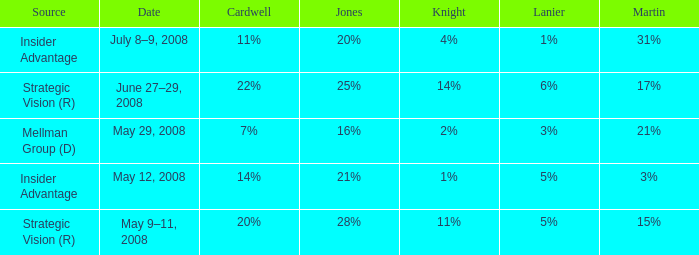Parse the table in full. {'header': ['Source', 'Date', 'Cardwell', 'Jones', 'Knight', 'Lanier', 'Martin'], 'rows': [['Insider Advantage', 'July 8–9, 2008', '11%', '20%', '4%', '1%', '31%'], ['Strategic Vision (R)', 'June 27–29, 2008', '22%', '25%', '14%', '6%', '17%'], ['Mellman Group (D)', 'May 29, 2008', '7%', '16%', '2%', '3%', '21%'], ['Insider Advantage', 'May 12, 2008', '14%', '21%', '1%', '5%', '3%'], ['Strategic Vision (R)', 'May 9–11, 2008', '20%', '28%', '11%', '5%', '15%']]} What source has a cardwell of 20%? Strategic Vision (R). 